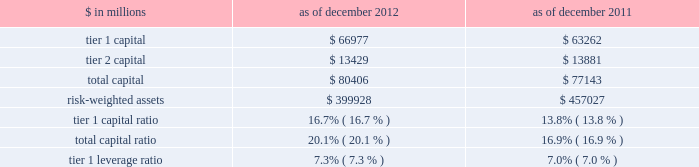Notes to consolidated financial statements note 20 .
Regulation and capital adequacy the federal reserve board is the primary regulator of group inc. , a bank holding company under the bank holding company act of 1956 ( bhc act ) and a financial holding company under amendments to the bhc act effected by the u.s .
Gramm-leach-bliley act of 1999 .
As a bank holding company , the firm is subject to consolidated regulatory capital requirements that are computed in accordance with the federal reserve board 2019s risk-based capital requirements ( which are based on the 2018basel 1 2019 capital accord of the basel committee ) .
These capital requirements are expressed as capital ratios that compare measures of capital to risk-weighted assets ( rwas ) .
The firm 2019s u.s .
Bank depository institution subsidiaries , including gs bank usa , are subject to similar capital requirements .
Under the federal reserve board 2019s capital adequacy requirements and the regulatory framework for prompt corrective action that is applicable to gs bank usa , the firm and its u.s .
Bank depository institution subsidiaries must meet specific capital requirements that involve quantitative measures of assets , liabilities and certain off- balance-sheet items as calculated under regulatory reporting practices .
The firm and its u.s .
Bank depository institution subsidiaries 2019 capital amounts , as well as gs bank usa 2019s prompt corrective action classification , are also subject to qualitative judgments by the regulators about components , risk weightings and other factors .
Many of the firm 2019s subsidiaries , including gs&co .
And the firm 2019s other broker-dealer subsidiaries , are subject to separate regulation and capital requirements as described below .
Group inc .
Federal reserve board regulations require bank holding companies to maintain a minimum tier 1 capital ratio of 4% ( 4 % ) and a minimum total capital ratio of 8% ( 8 % ) .
The required minimum tier 1 capital ratio and total capital ratio in order to be considered a 201cwell-capitalized 201d bank holding company under the federal reserve board guidelines are 6% ( 6 % ) and 10% ( 10 % ) , respectively .
Bank holding companies may be expected to maintain ratios well above the minimum levels , depending on their particular condition , risk profile and growth plans .
The minimum tier 1 leverage ratio is 3% ( 3 % ) for bank holding companies that have received the highest supervisory rating under federal reserve board guidelines or that have implemented the federal reserve board 2019s risk-based capital measure for market risk .
Other bank holding companies must have a minimum tier 1 leverage ratio of 4% ( 4 % ) .
The table below presents information regarding group inc . 2019s regulatory capital ratios. .
Rwas under the federal reserve board 2019s risk-based capital requirements are calculated based on the amount of market risk and credit risk .
Rwas for market risk are determined by reference to the firm 2019s value-at-risk ( var ) model , supplemented by other measures to capture risks not reflected in the firm 2019s var model .
Credit risk for on- balance sheet assets is based on the balance sheet value .
For off-balance sheet exposures , including otc derivatives and commitments , a credit equivalent amount is calculated based on the notional amount of each trade .
All such assets and exposures are then assigned a risk weight depending on , among other things , whether the counterparty is a sovereign , bank or a qualifying securities firm or other entity ( or if collateral is held , depending on the nature of the collateral ) .
Tier 1 leverage ratio is defined as tier 1 capital under basel 1 divided by average adjusted total assets ( which includes adjustments for disallowed goodwill and intangible assets , and the carrying value of equity investments in non-financial companies that are subject to deductions from tier 1 capital ) .
184 goldman sachs 2012 annual report .
For federal reserve board regulations requiring bank holding companies to maintain a minimum tier 1 capital ratio , what is the range of the minimum total capital ratio in percentage points ? .? 
Computations: (8 - 4)
Answer: 4.0. 